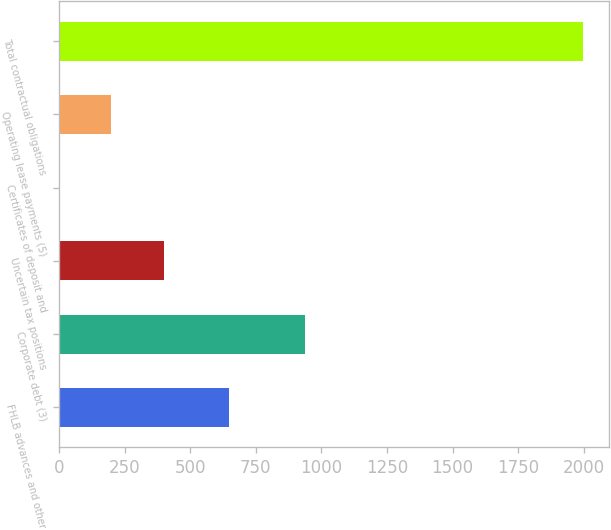<chart> <loc_0><loc_0><loc_500><loc_500><bar_chart><fcel>FHLB advances and other<fcel>Corporate debt (3)<fcel>Uncertain tax positions<fcel>Certificates of deposit and<fcel>Operating lease payments (5)<fcel>Total contractual obligations<nl><fcel>648.2<fcel>938.3<fcel>399.82<fcel>0.4<fcel>200.11<fcel>1997.5<nl></chart> 